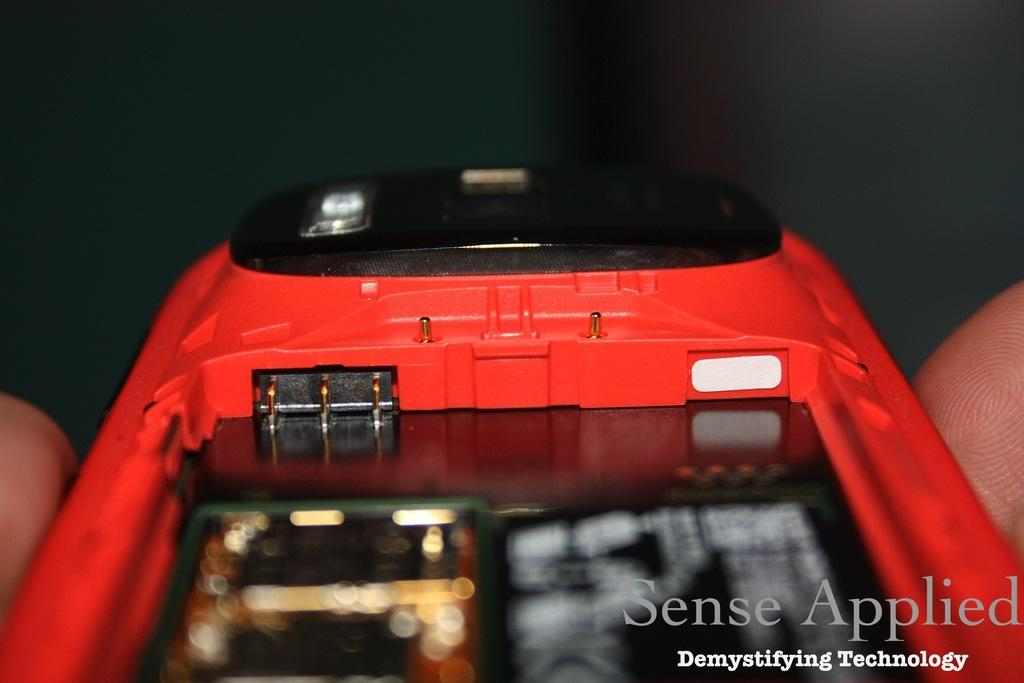<image>
Offer a succinct explanation of the picture presented. A person is holding a phone without the battery and the words, 'Sense Applied', is superimposed on the image. 